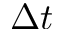<formula> <loc_0><loc_0><loc_500><loc_500>\Delta t</formula> 